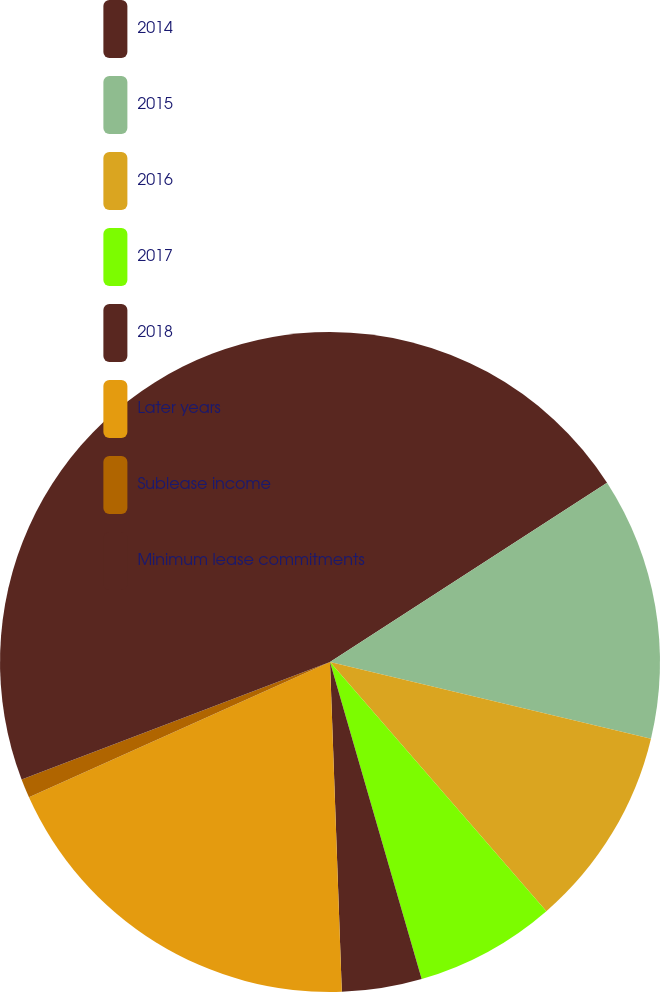<chart> <loc_0><loc_0><loc_500><loc_500><pie_chart><fcel>2014<fcel>2015<fcel>2016<fcel>2017<fcel>2018<fcel>Later years<fcel>Sublease income<fcel>Minimum lease commitments<nl><fcel>15.86%<fcel>12.87%<fcel>9.89%<fcel>6.9%<fcel>3.91%<fcel>18.85%<fcel>0.93%<fcel>30.79%<nl></chart> 